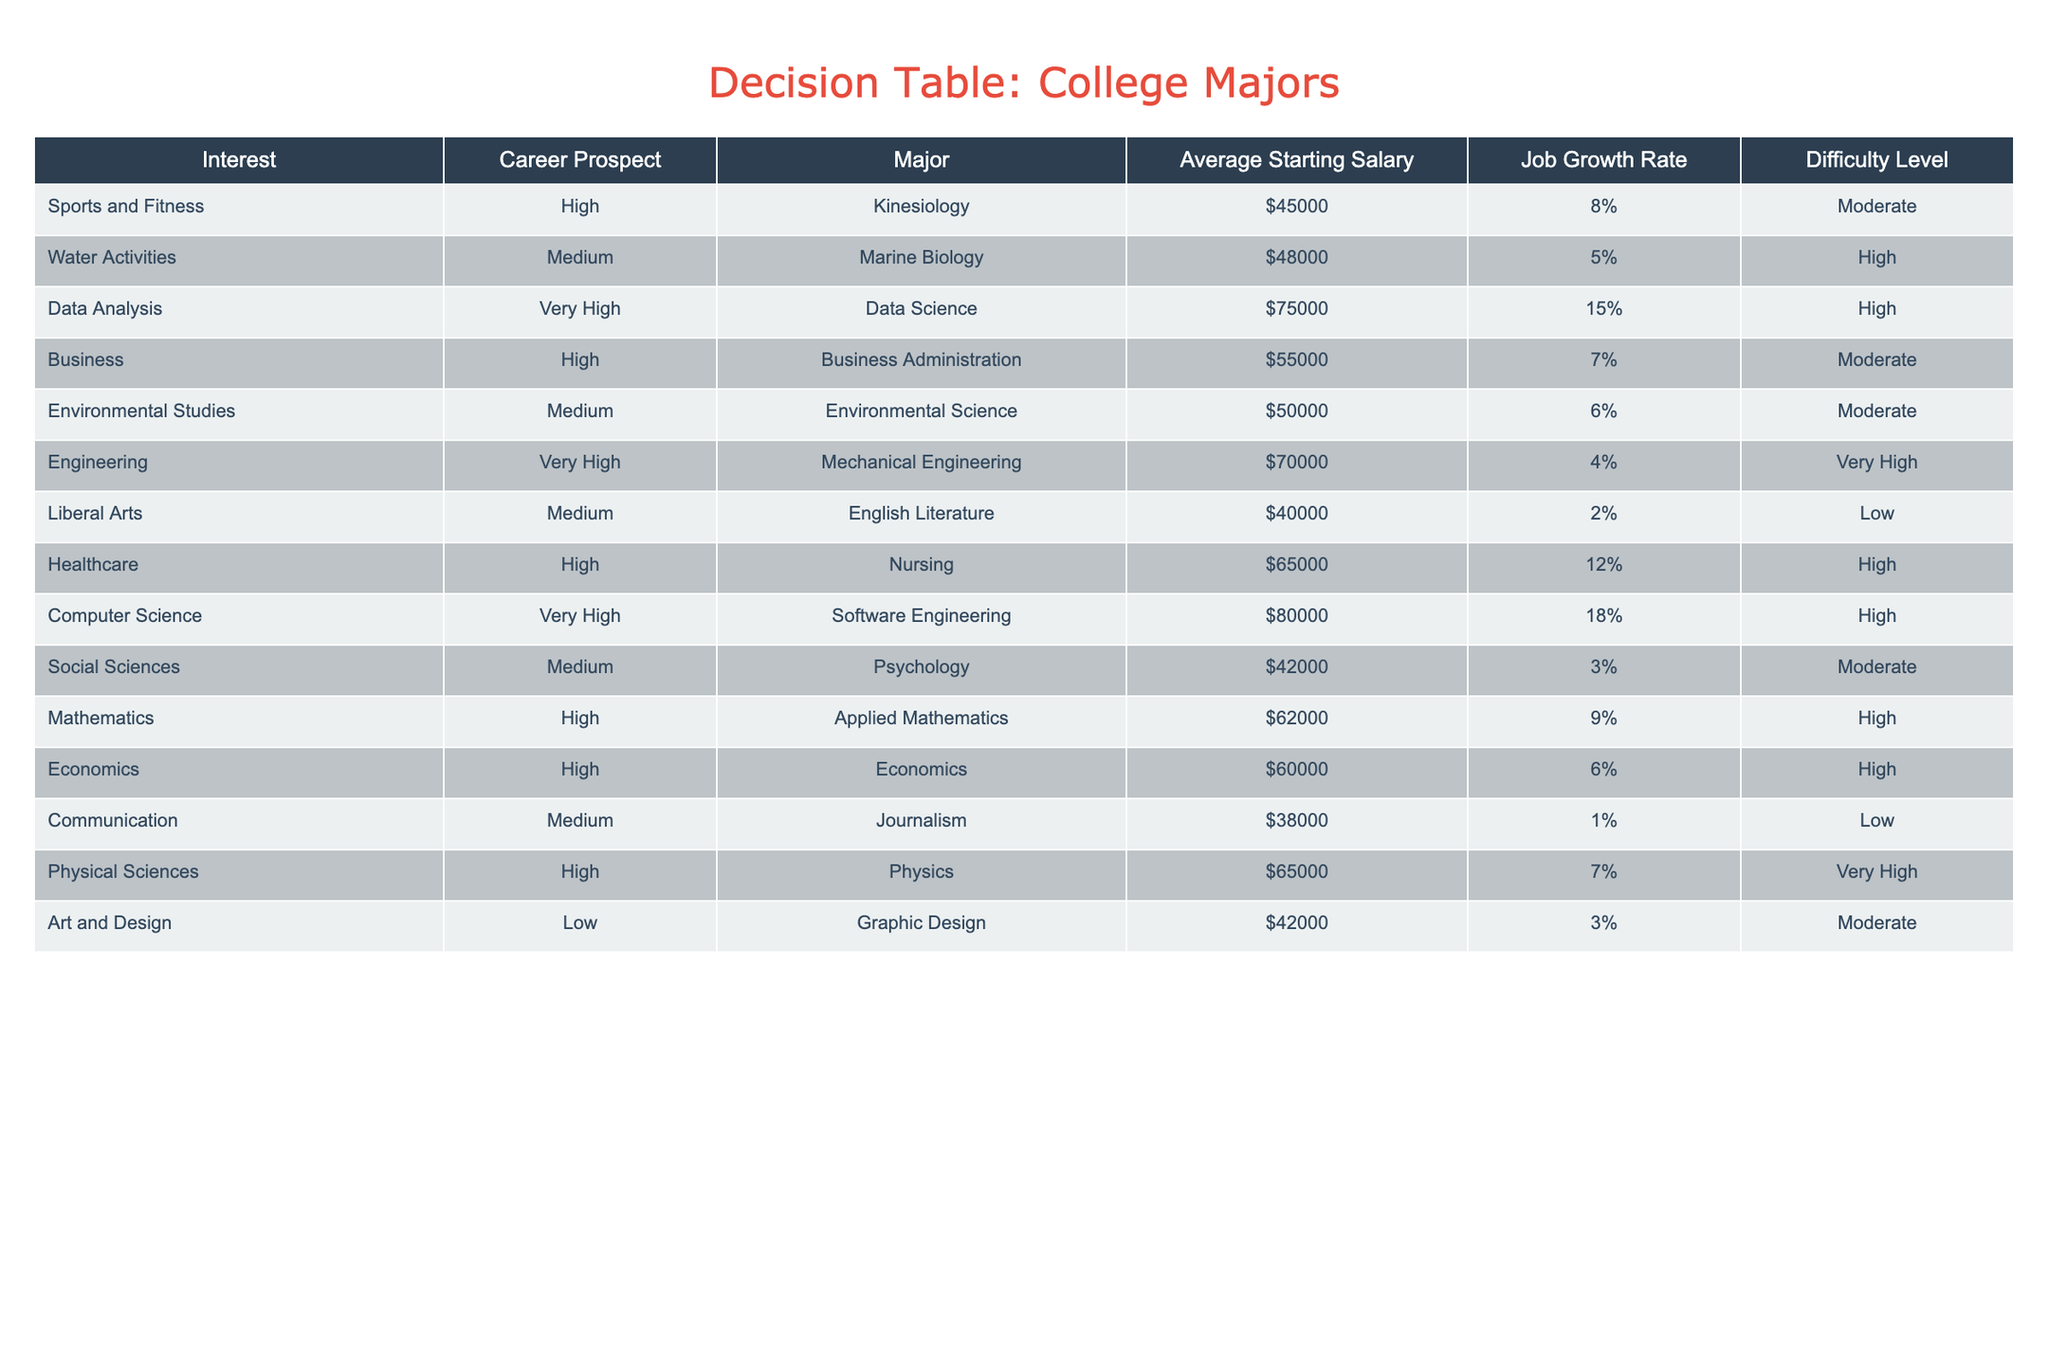What is the average starting salary for a major in Kinesiology? The table lists Kinesiology under the Major column with an Average Starting Salary of $45000. Thus, the average starting salary for this major is directly taken from the table.
Answer: 45000 Which major has the highest job growth rate? The table shows different job growth rates, with Computer Science having the highest at 18%. To find this, we look at the Job Growth Rate column and identify the maximum value.
Answer: Computer Science Are there any majors with a low difficulty level that also have a high career prospect? According to the table, the majors that are marked with low difficulty level do not fall under high career prospects; English Literature and Graphic Design have medium or low levels of career prospects. Thus, there are no such majors.
Answer: No What is the difference in average starting salary between Data Science and Nursing? The average starting salary for Data Science is $75000, while for Nursing it is $65000. To find the difference, we calculate $75000 - $65000, which equals $10000.
Answer: 10000 Based on the data, is it true that all majors with very high career prospects also have a high average starting salary? The majors with very high career prospects are Data Science, Computer Science, and Mechanical Engineering. Their average starting salaries are $75000, $80000, and $70000 respectively, which are all high. Thus, the answer is true.
Answer: Yes What is the average job growth rate for the majors listed under medium career prospects? For the majors with medium prospects, the job growth rates are 5%, 6%, 3%, and 1%. To find the average, we add these rates (5 + 6 + 3 + 1 = 15) and divide by 4, giving 15/4 = 3.75%.
Answer: 3.75% Which major offers a higher starting salary: Environmental Science or Applied Mathematics? Environmental Science has an average starting salary of $50000, while Applied Mathematics has $62000. By comparing these two values, we see that Applied Mathematics has a higher salary.
Answer: Applied Mathematics How many majors have a job growth rate above 10%? Looking at the Job Growth Rate column, we can identify those above 10%, which are Data Science (15%), Nursing (12%), and Computer Science (18%). Counting these gives us a total of 3 majors.
Answer: 3 